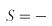<formula> <loc_0><loc_0><loc_500><loc_500>S = -</formula> 